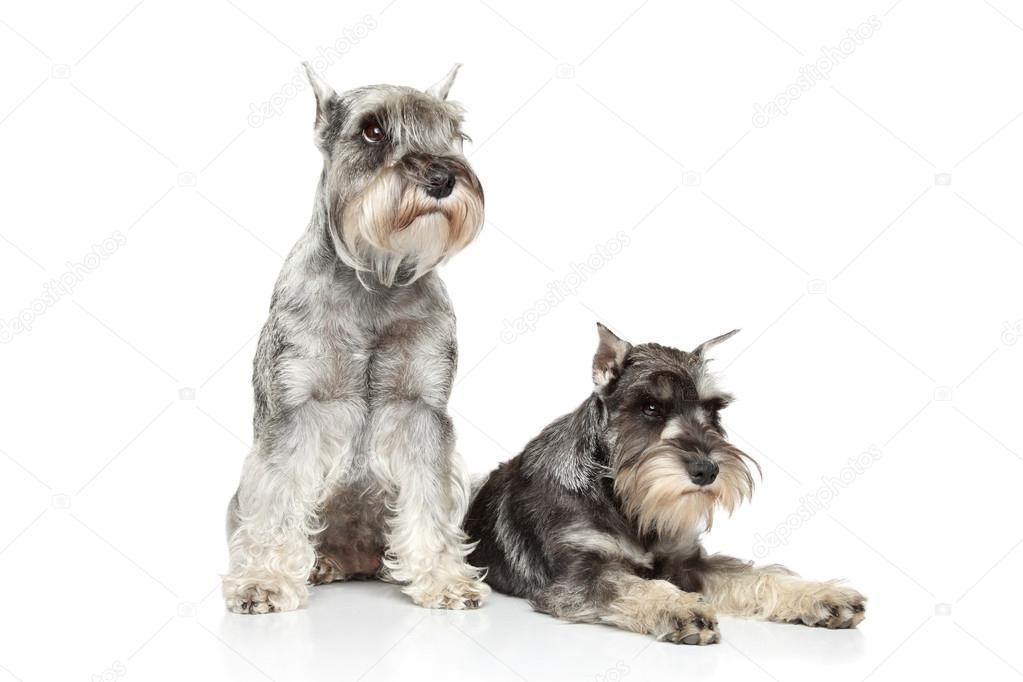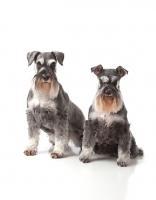The first image is the image on the left, the second image is the image on the right. Considering the images on both sides, is "There are two dogs in each image." valid? Answer yes or no. Yes. The first image is the image on the left, the second image is the image on the right. Assess this claim about the two images: "A total of two schnauzer dogs are shown, including one reclining with extended front paws.". Correct or not? Answer yes or no. No. 